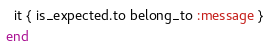<code> <loc_0><loc_0><loc_500><loc_500><_Ruby_>  it { is_expected.to belong_to :message }
end
</code> 